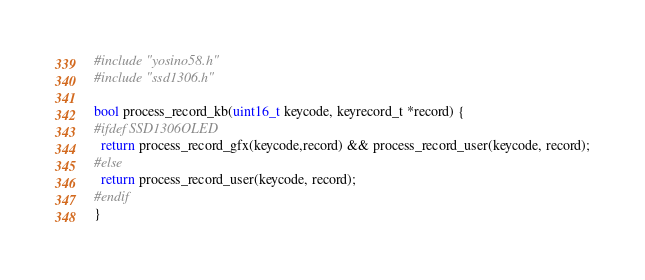<code> <loc_0><loc_0><loc_500><loc_500><_C_>#include "yosino58.h"
#include "ssd1306.h"

bool process_record_kb(uint16_t keycode, keyrecord_t *record) {
#ifdef SSD1306OLED
  return process_record_gfx(keycode,record) && process_record_user(keycode, record);
#else
  return process_record_user(keycode, record);
#endif
}
</code> 